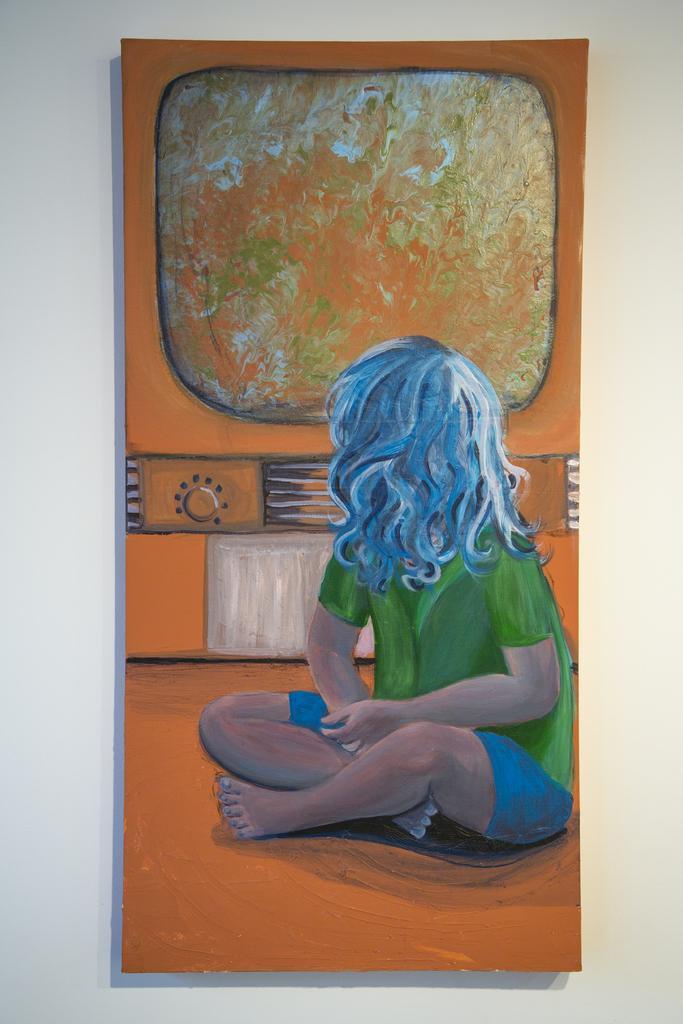Can you describe this image briefly? In this image I can see the board to the white wall. In the board I can see the painting of person and the person is wearing the green and blue color dress. To the right of the person I can see the window. 